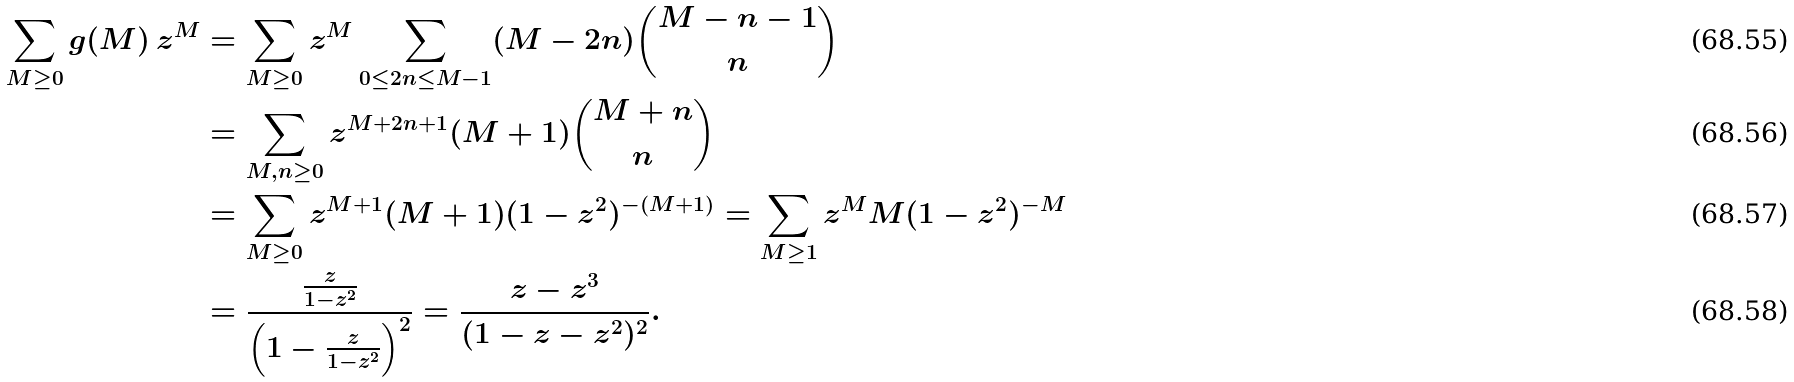<formula> <loc_0><loc_0><loc_500><loc_500>\sum _ { M \geq 0 } g ( M ) \, z ^ { M } & = \sum _ { M \geq 0 } z ^ { M } \sum _ { 0 \leq 2 n \leq M - 1 } ( M - 2 n ) \binom { M - n - 1 } n \\ & = \sum _ { M , n \geq 0 } z ^ { M + 2 n + 1 } ( M + 1 ) \binom { M + n } n \\ & = \sum _ { M \geq 0 } { z ^ { M + 1 } ( M + 1 ) } { ( 1 - z ^ { 2 } ) ^ { - ( M + 1 ) } } = \sum _ { M \geq 1 } { z ^ { M } M } { ( 1 - z ^ { 2 } ) ^ { - M } } \\ & = \frac { \frac { z } { 1 - z ^ { 2 } } } { \left ( 1 - \frac { z } { 1 - z ^ { 2 } } \right ) ^ { 2 } } = \frac { z - z ^ { 3 } } { ( 1 - z - z ^ { 2 } ) ^ { 2 } } .</formula> 